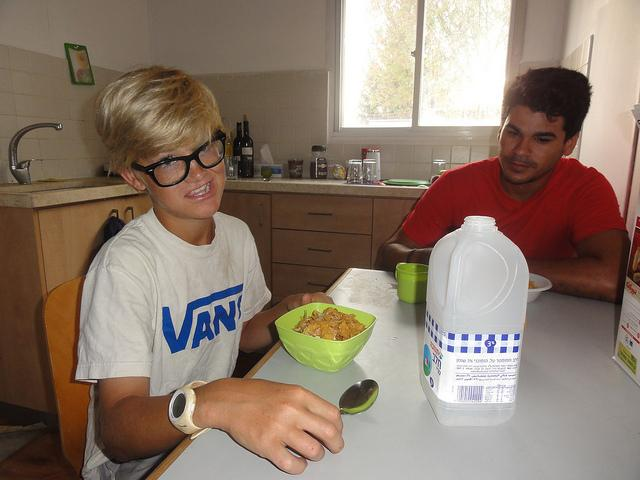What commodity has this young man exhausted? milk 